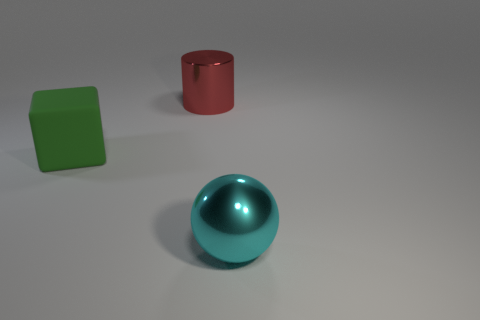Is there any other thing that is the same material as the big cube?
Give a very brief answer. No. Are there any large metallic things?
Give a very brief answer. Yes. There is a metal thing behind the green rubber cube; what is its size?
Provide a short and direct response. Large. What number of large metallic objects are the same color as the big block?
Keep it short and to the point. 0. How many spheres are big green objects or big cyan shiny objects?
Offer a very short reply. 1. What shape is the big object that is both to the left of the large cyan metallic object and in front of the large red object?
Offer a terse response. Cube. Is there a green ball that has the same size as the cylinder?
Your response must be concise. No. How many things are either large things that are on the left side of the red shiny cylinder or large red spheres?
Your answer should be very brief. 1. Does the cylinder have the same material as the big object that is on the right side of the big red cylinder?
Ensure brevity in your answer.  Yes. How many other things are the same shape as the large green matte thing?
Keep it short and to the point. 0. 